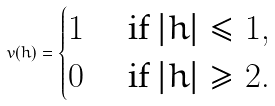Convert formula to latex. <formula><loc_0><loc_0><loc_500><loc_500>v ( h ) = \begin{cases} 1 & \text { if } | h | \leq 1 , \\ 0 & \text { if } | h | \geq 2 . \end{cases}</formula> 